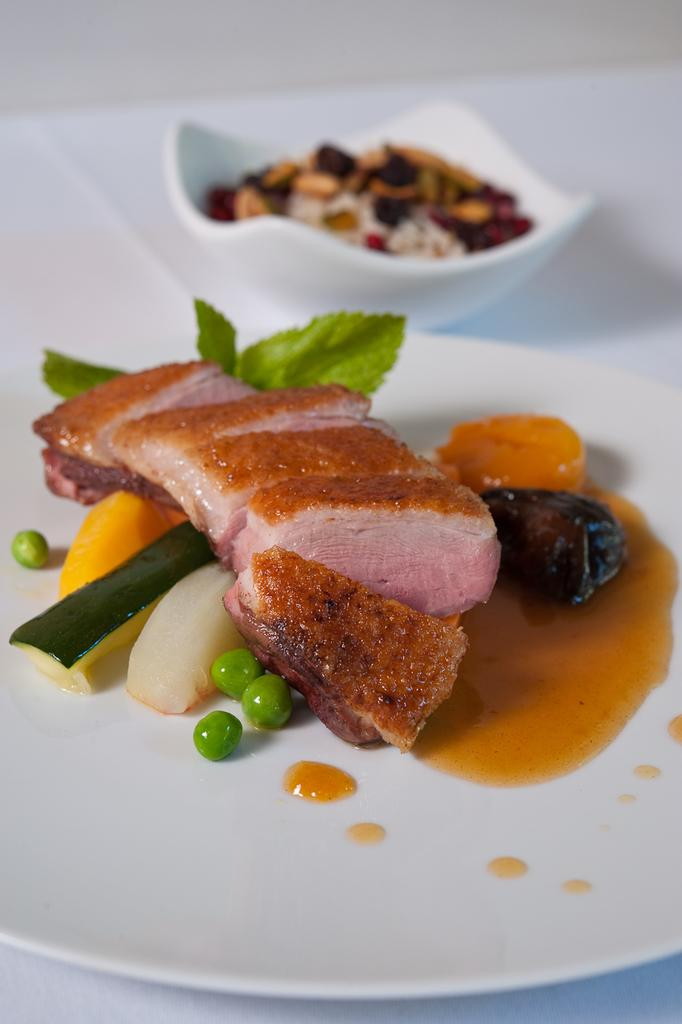What type of food items can be seen on the plate in the image? The specific type of food items on the plate cannot be determined from the provided facts. What type of food items can be seen in the bowl in the image? The specific type of food items in the bowl cannot be determined from the provided facts. What is the object that the plate and bowl are placed on? The object on which the plate and bowl are placed cannot be determined from the provided facts. What religious symbols can be seen in the field in the image? There is no mention of a field or religious symbols in the provided facts, so this question cannot be answered. 